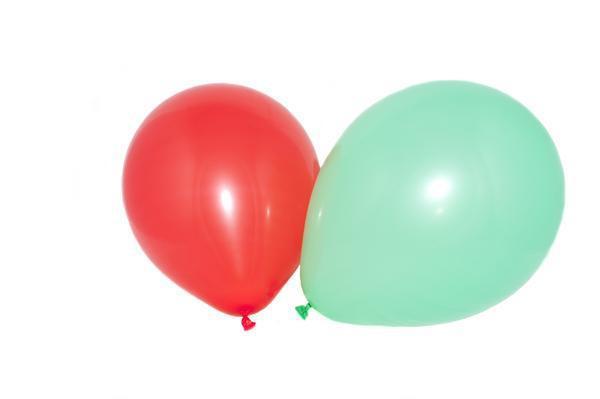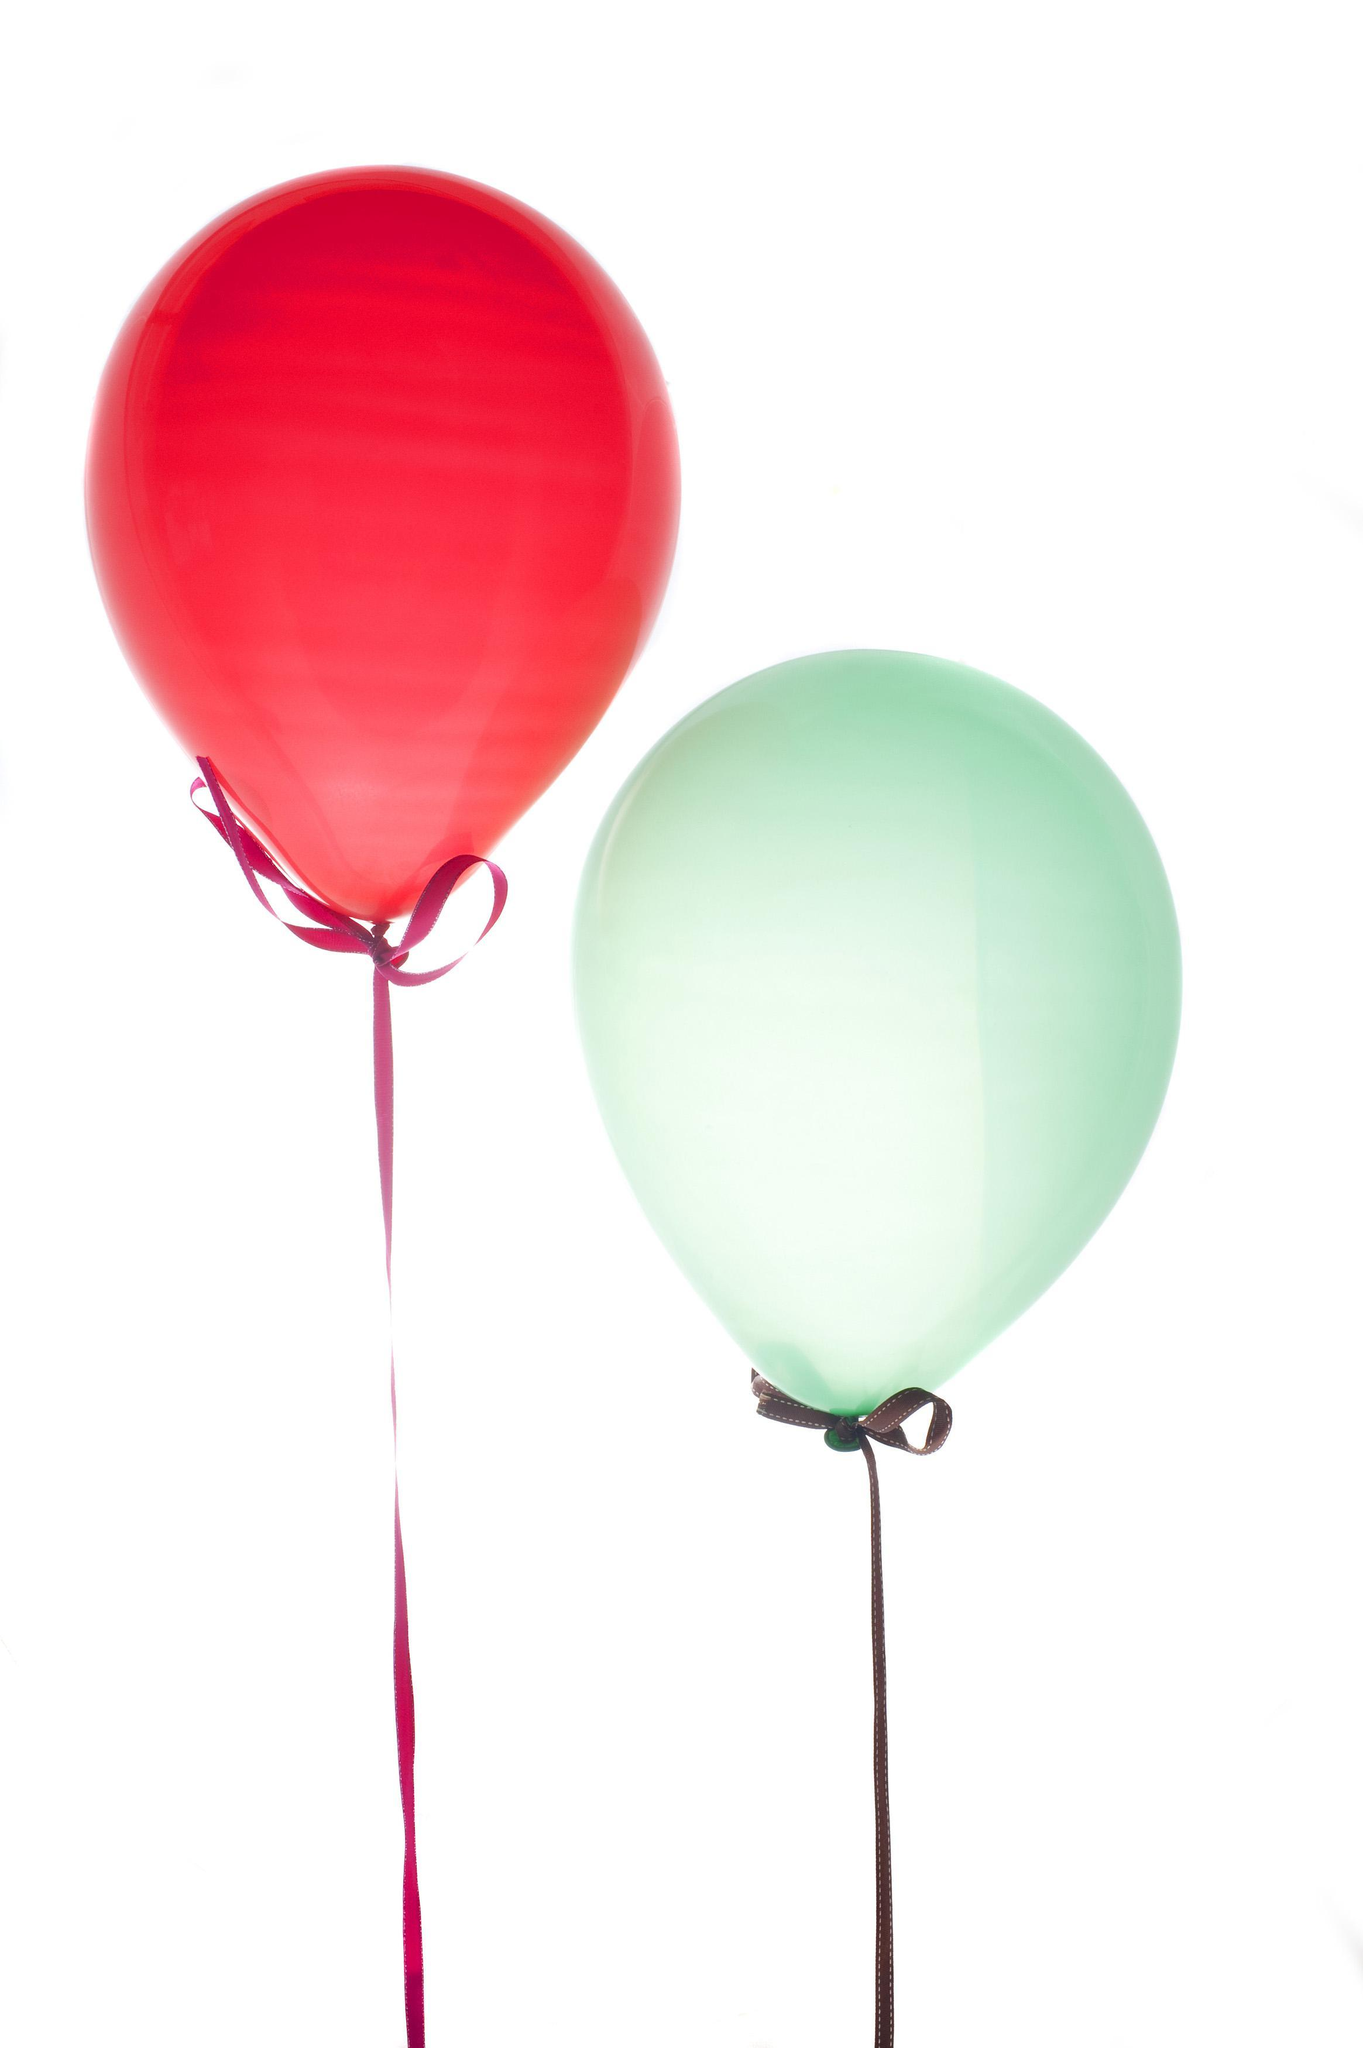The first image is the image on the left, the second image is the image on the right. Considering the images on both sides, is "Each image shows one round red balloon and one round green balloon side by side" valid? Answer yes or no. Yes. The first image is the image on the left, the second image is the image on the right. Assess this claim about the two images: "Each image shows exactly one aqua balloon next to one red balloon.". Correct or not? Answer yes or no. Yes. 